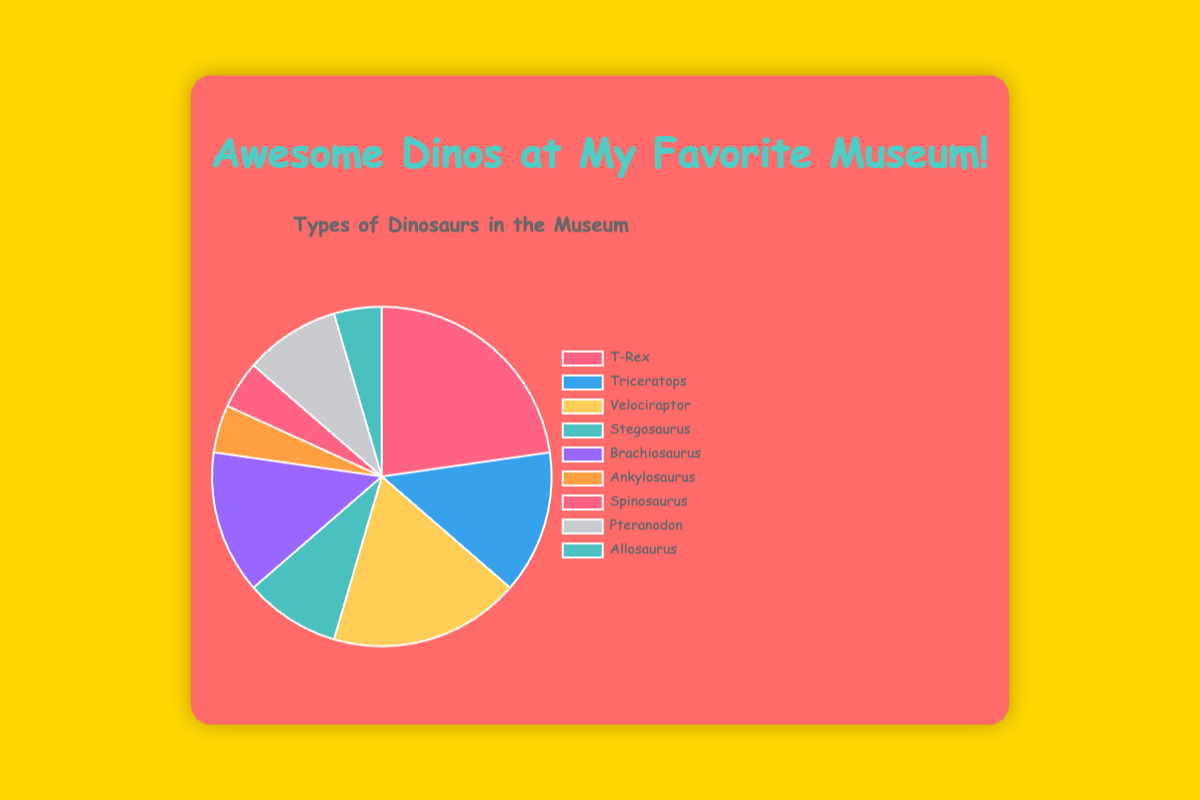Which dinosaur type is exhibited the most? The pie chart shows that Tyrannosaurus Rex has the largest section, meaning it has the highest count among all dinosaur types displayed.
Answer: Tyrannosaurus Rex Which dinosaur types have the same count? By looking at the pie chart, Triceratops and Brachiosaurus both have equal-length sections, indicating they have the same count. Velociraptor and Pteranodon also have the same count.
Answer: Triceratops and Brachiosaurus; Velociraptor and Pteranodon How many more Tyrannosaurus Rex are there than Ankylosaurus? The pie chart indicates that Tyrannosaurus Rex has a count of 5 and Ankylosaurus has a count of 1. The difference is 5 - 1.
Answer: 4 What proportion of the total dinosaur exhibits are Triceratops? The total count of dinosaurs is 22. Triceratops make up 3 of these. The proportion is calculated as 3 / 22.
Answer: 3 / 22 or approximately 0.136 Are there more Velociraptors or Stegosauruses? The pie chart shows that Velociraptor has a larger section than Stegosaurus, indicating that there are more Velociraptors.
Answer: Velociraptors What color is used to represent Brachiosaurus on the pie chart? The pie chart shows different colors for each dinosaur type, and Brachiosaurus is represented by a purple color.
Answer: Purple What is the combined count of Spinosaurus and Allosaurus? The pie chart sections for Spinosaurus and Allosaurus show counts of 1 each. Adding these together gives 1 + 1.
Answer: 2 Which dinosaur type has the smallest representation on the chart? The pie chart shows that Ankylosaurus, Spinosaurus, and Allosaurus each have the smallest sections, each representing a count of 1.
Answer: Ankylosaurus, Spinosaurus, and Allosaurus What is the total count of dinosaurs exhibited in the museum? Summing up the counts of all dinosaur types from the pie chart: 5 (Tyrannosaurus Rex) + 3 (Triceratops) + 4 (Velociraptor) + 2 (Stegosaurus) + 3 (Brachiosaurus) + 1 (Ankylosaurus) + 1 (Spinosaurus) + 2 (Pteranodon) + 1 (Allosaurus).
Answer: 22 